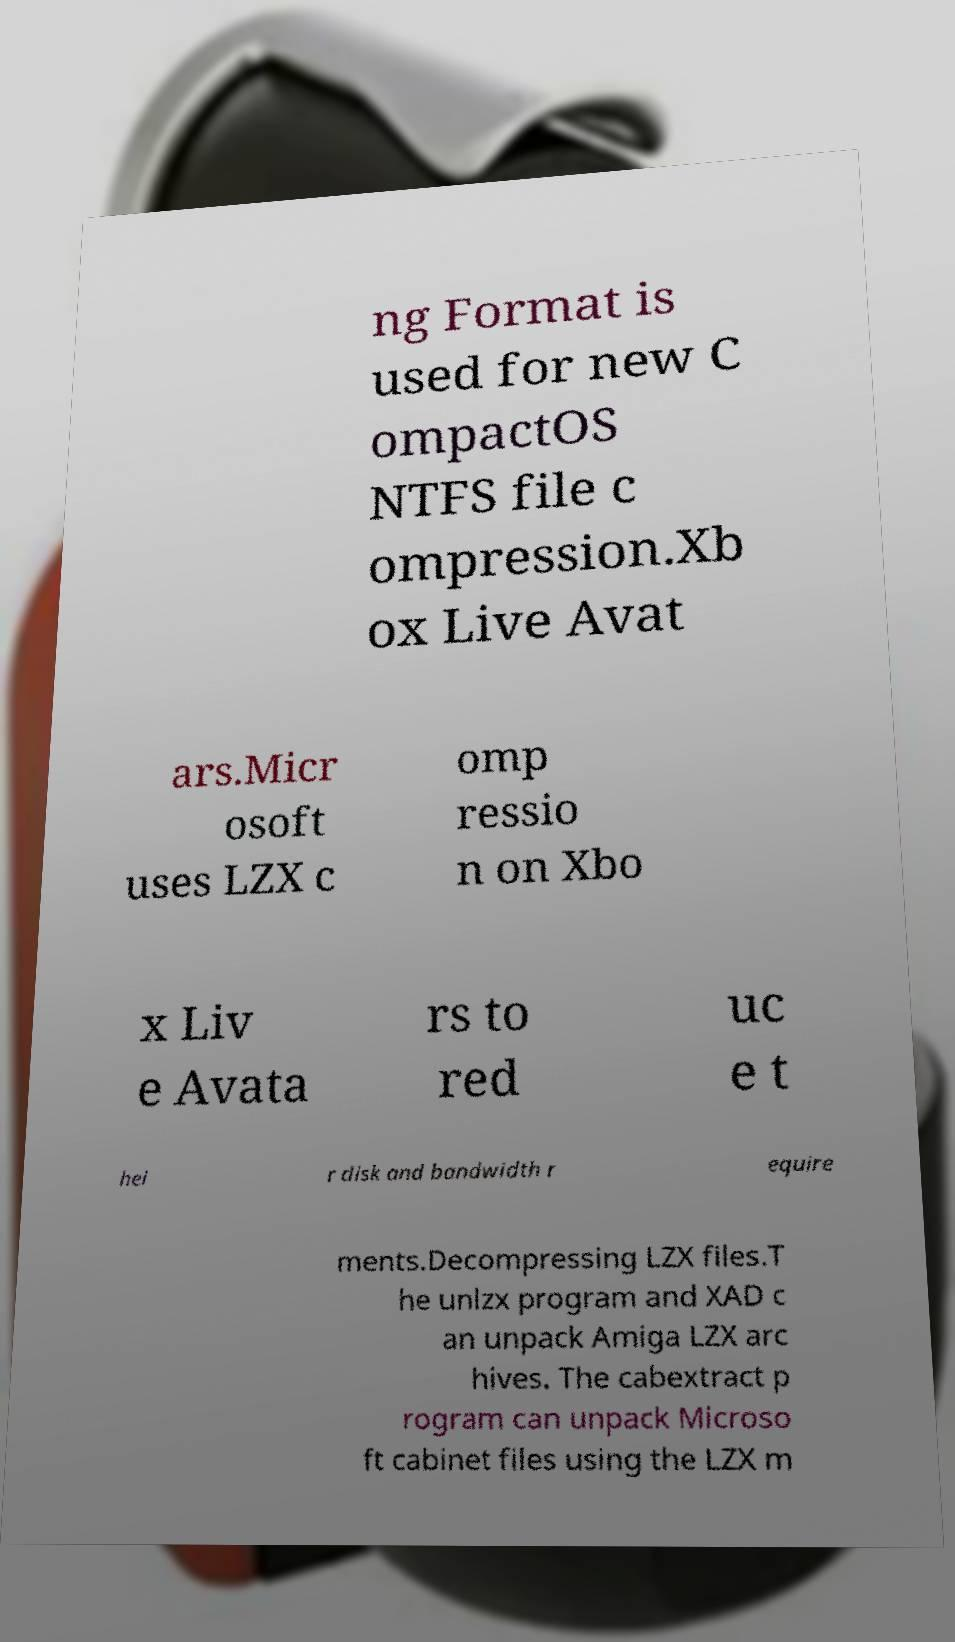Please identify and transcribe the text found in this image. ng Format is used for new C ompactOS NTFS file c ompression.Xb ox Live Avat ars.Micr osoft uses LZX c omp ressio n on Xbo x Liv e Avata rs to red uc e t hei r disk and bandwidth r equire ments.Decompressing LZX files.T he unlzx program and XAD c an unpack Amiga LZX arc hives. The cabextract p rogram can unpack Microso ft cabinet files using the LZX m 